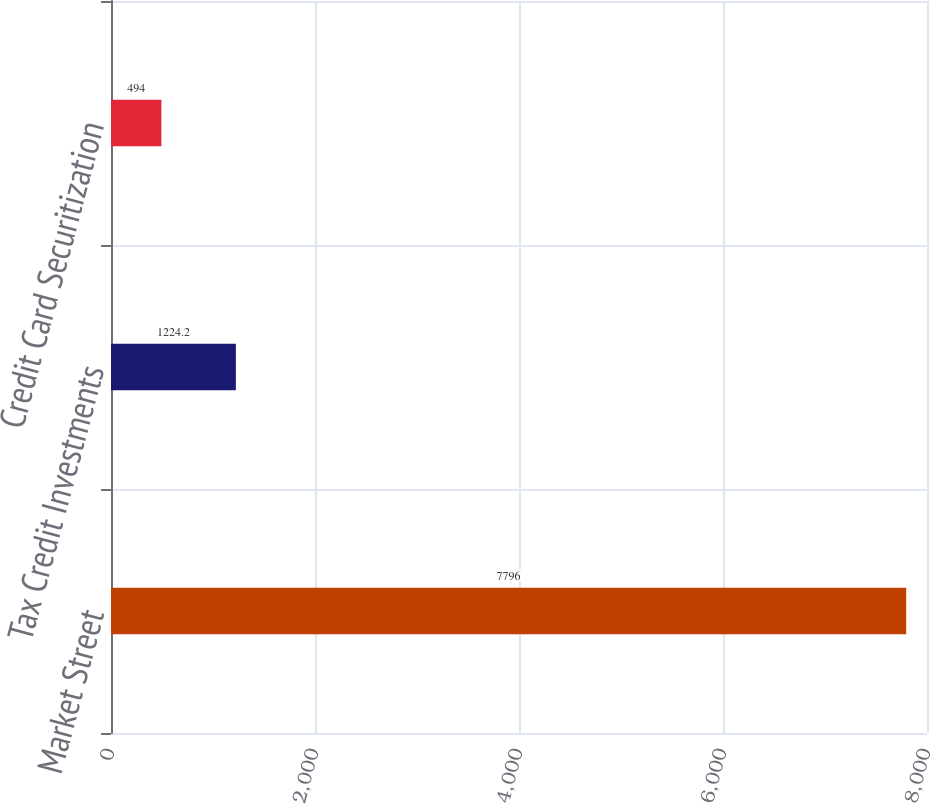<chart> <loc_0><loc_0><loc_500><loc_500><bar_chart><fcel>Market Street<fcel>Tax Credit Investments<fcel>Credit Card Securitization<nl><fcel>7796<fcel>1224.2<fcel>494<nl></chart> 